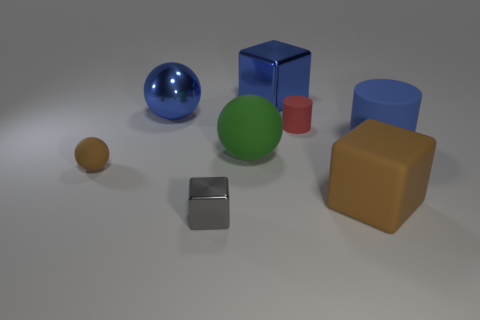Add 2 tiny gray metallic things. How many objects exist? 10 Subtract all spheres. How many objects are left? 5 Add 7 cubes. How many cubes exist? 10 Subtract 0 purple cubes. How many objects are left? 8 Subtract all blue cylinders. Subtract all blue objects. How many objects are left? 4 Add 2 small rubber things. How many small rubber things are left? 4 